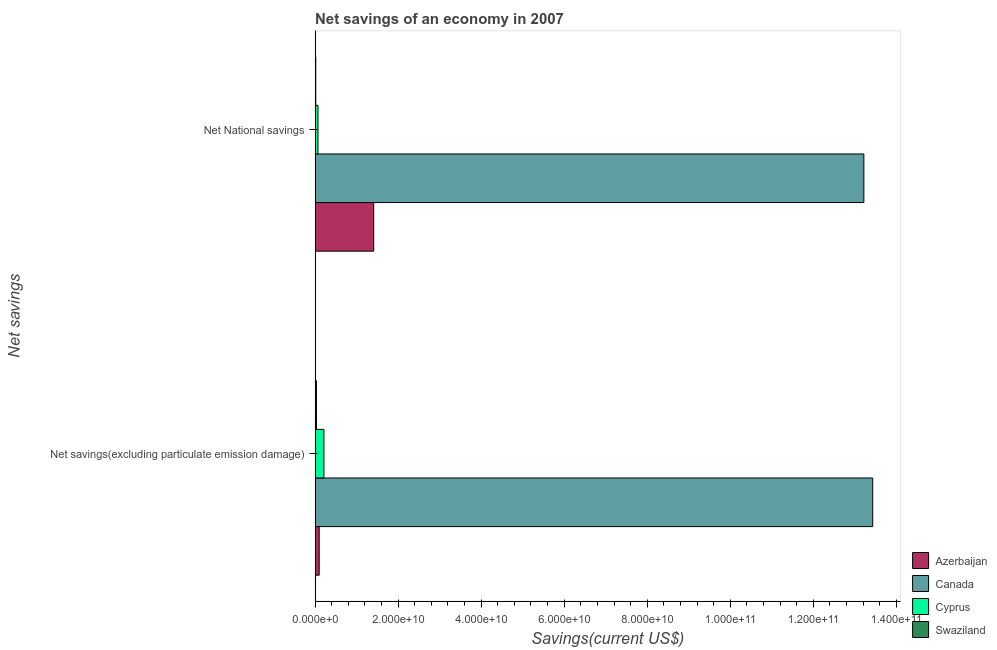Are the number of bars per tick equal to the number of legend labels?
Give a very brief answer. Yes. Are the number of bars on each tick of the Y-axis equal?
Give a very brief answer. Yes. How many bars are there on the 1st tick from the top?
Make the answer very short. 4. How many bars are there on the 1st tick from the bottom?
Ensure brevity in your answer.  4. What is the label of the 1st group of bars from the top?
Offer a terse response. Net National savings. What is the net savings(excluding particulate emission damage) in Cyprus?
Make the answer very short. 2.13e+09. Across all countries, what is the maximum net national savings?
Your answer should be compact. 1.32e+11. Across all countries, what is the minimum net national savings?
Your response must be concise. 1.61e+08. In which country was the net savings(excluding particulate emission damage) maximum?
Make the answer very short. Canada. In which country was the net national savings minimum?
Give a very brief answer. Swaziland. What is the total net national savings in the graph?
Provide a succinct answer. 1.47e+11. What is the difference between the net savings(excluding particulate emission damage) in Cyprus and that in Canada?
Ensure brevity in your answer.  -1.32e+11. What is the difference between the net savings(excluding particulate emission damage) in Canada and the net national savings in Swaziland?
Your response must be concise. 1.34e+11. What is the average net savings(excluding particulate emission damage) per country?
Make the answer very short. 3.44e+1. What is the difference between the net national savings and net savings(excluding particulate emission damage) in Swaziland?
Offer a terse response. -1.59e+08. In how many countries, is the net savings(excluding particulate emission damage) greater than 20000000000 US$?
Provide a short and direct response. 1. What is the ratio of the net savings(excluding particulate emission damage) in Cyprus to that in Canada?
Ensure brevity in your answer.  0.02. Is the net national savings in Swaziland less than that in Canada?
Give a very brief answer. Yes. What does the 2nd bar from the top in Net National savings represents?
Ensure brevity in your answer.  Cyprus. What does the 4th bar from the bottom in Net savings(excluding particulate emission damage) represents?
Provide a short and direct response. Swaziland. How many countries are there in the graph?
Ensure brevity in your answer.  4. What is the difference between two consecutive major ticks on the X-axis?
Provide a short and direct response. 2.00e+1. Are the values on the major ticks of X-axis written in scientific E-notation?
Provide a succinct answer. Yes. Where does the legend appear in the graph?
Offer a terse response. Bottom right. How are the legend labels stacked?
Offer a very short reply. Vertical. What is the title of the graph?
Your answer should be very brief. Net savings of an economy in 2007. What is the label or title of the X-axis?
Your answer should be compact. Savings(current US$). What is the label or title of the Y-axis?
Give a very brief answer. Net savings. What is the Savings(current US$) of Azerbaijan in Net savings(excluding particulate emission damage)?
Provide a succinct answer. 9.83e+08. What is the Savings(current US$) in Canada in Net savings(excluding particulate emission damage)?
Keep it short and to the point. 1.34e+11. What is the Savings(current US$) of Cyprus in Net savings(excluding particulate emission damage)?
Offer a very short reply. 2.13e+09. What is the Savings(current US$) in Swaziland in Net savings(excluding particulate emission damage)?
Provide a short and direct response. 3.20e+08. What is the Savings(current US$) in Azerbaijan in Net National savings?
Provide a short and direct response. 1.41e+1. What is the Savings(current US$) in Canada in Net National savings?
Offer a very short reply. 1.32e+11. What is the Savings(current US$) of Cyprus in Net National savings?
Your answer should be compact. 6.94e+08. What is the Savings(current US$) of Swaziland in Net National savings?
Your answer should be compact. 1.61e+08. Across all Net savings, what is the maximum Savings(current US$) of Azerbaijan?
Provide a succinct answer. 1.41e+1. Across all Net savings, what is the maximum Savings(current US$) of Canada?
Ensure brevity in your answer.  1.34e+11. Across all Net savings, what is the maximum Savings(current US$) in Cyprus?
Give a very brief answer. 2.13e+09. Across all Net savings, what is the maximum Savings(current US$) of Swaziland?
Your response must be concise. 3.20e+08. Across all Net savings, what is the minimum Savings(current US$) of Azerbaijan?
Give a very brief answer. 9.83e+08. Across all Net savings, what is the minimum Savings(current US$) of Canada?
Offer a very short reply. 1.32e+11. Across all Net savings, what is the minimum Savings(current US$) in Cyprus?
Your answer should be compact. 6.94e+08. Across all Net savings, what is the minimum Savings(current US$) in Swaziland?
Offer a terse response. 1.61e+08. What is the total Savings(current US$) in Azerbaijan in the graph?
Your answer should be compact. 1.51e+1. What is the total Savings(current US$) of Canada in the graph?
Provide a succinct answer. 2.67e+11. What is the total Savings(current US$) of Cyprus in the graph?
Your answer should be compact. 2.82e+09. What is the total Savings(current US$) of Swaziland in the graph?
Make the answer very short. 4.81e+08. What is the difference between the Savings(current US$) of Azerbaijan in Net savings(excluding particulate emission damage) and that in Net National savings?
Your response must be concise. -1.31e+1. What is the difference between the Savings(current US$) of Canada in Net savings(excluding particulate emission damage) and that in Net National savings?
Ensure brevity in your answer.  2.13e+09. What is the difference between the Savings(current US$) of Cyprus in Net savings(excluding particulate emission damage) and that in Net National savings?
Give a very brief answer. 1.44e+09. What is the difference between the Savings(current US$) in Swaziland in Net savings(excluding particulate emission damage) and that in Net National savings?
Make the answer very short. 1.59e+08. What is the difference between the Savings(current US$) in Azerbaijan in Net savings(excluding particulate emission damage) and the Savings(current US$) in Canada in Net National savings?
Offer a terse response. -1.31e+11. What is the difference between the Savings(current US$) of Azerbaijan in Net savings(excluding particulate emission damage) and the Savings(current US$) of Cyprus in Net National savings?
Offer a terse response. 2.88e+08. What is the difference between the Savings(current US$) of Azerbaijan in Net savings(excluding particulate emission damage) and the Savings(current US$) of Swaziland in Net National savings?
Offer a very short reply. 8.21e+08. What is the difference between the Savings(current US$) of Canada in Net savings(excluding particulate emission damage) and the Savings(current US$) of Cyprus in Net National savings?
Offer a very short reply. 1.34e+11. What is the difference between the Savings(current US$) of Canada in Net savings(excluding particulate emission damage) and the Savings(current US$) of Swaziland in Net National savings?
Your answer should be compact. 1.34e+11. What is the difference between the Savings(current US$) of Cyprus in Net savings(excluding particulate emission damage) and the Savings(current US$) of Swaziland in Net National savings?
Your response must be concise. 1.97e+09. What is the average Savings(current US$) in Azerbaijan per Net savings?
Offer a terse response. 7.55e+09. What is the average Savings(current US$) of Canada per Net savings?
Offer a terse response. 1.33e+11. What is the average Savings(current US$) in Cyprus per Net savings?
Ensure brevity in your answer.  1.41e+09. What is the average Savings(current US$) of Swaziland per Net savings?
Offer a very short reply. 2.41e+08. What is the difference between the Savings(current US$) in Azerbaijan and Savings(current US$) in Canada in Net savings(excluding particulate emission damage)?
Keep it short and to the point. -1.33e+11. What is the difference between the Savings(current US$) of Azerbaijan and Savings(current US$) of Cyprus in Net savings(excluding particulate emission damage)?
Your answer should be compact. -1.15e+09. What is the difference between the Savings(current US$) in Azerbaijan and Savings(current US$) in Swaziland in Net savings(excluding particulate emission damage)?
Give a very brief answer. 6.63e+08. What is the difference between the Savings(current US$) of Canada and Savings(current US$) of Cyprus in Net savings(excluding particulate emission damage)?
Your response must be concise. 1.32e+11. What is the difference between the Savings(current US$) in Canada and Savings(current US$) in Swaziland in Net savings(excluding particulate emission damage)?
Make the answer very short. 1.34e+11. What is the difference between the Savings(current US$) of Cyprus and Savings(current US$) of Swaziland in Net savings(excluding particulate emission damage)?
Provide a succinct answer. 1.81e+09. What is the difference between the Savings(current US$) in Azerbaijan and Savings(current US$) in Canada in Net National savings?
Provide a succinct answer. -1.18e+11. What is the difference between the Savings(current US$) of Azerbaijan and Savings(current US$) of Cyprus in Net National savings?
Ensure brevity in your answer.  1.34e+1. What is the difference between the Savings(current US$) of Azerbaijan and Savings(current US$) of Swaziland in Net National savings?
Provide a succinct answer. 1.40e+1. What is the difference between the Savings(current US$) in Canada and Savings(current US$) in Cyprus in Net National savings?
Offer a terse response. 1.31e+11. What is the difference between the Savings(current US$) in Canada and Savings(current US$) in Swaziland in Net National savings?
Provide a short and direct response. 1.32e+11. What is the difference between the Savings(current US$) in Cyprus and Savings(current US$) in Swaziland in Net National savings?
Your response must be concise. 5.33e+08. What is the ratio of the Savings(current US$) of Azerbaijan in Net savings(excluding particulate emission damage) to that in Net National savings?
Your answer should be very brief. 0.07. What is the ratio of the Savings(current US$) in Canada in Net savings(excluding particulate emission damage) to that in Net National savings?
Offer a very short reply. 1.02. What is the ratio of the Savings(current US$) in Cyprus in Net savings(excluding particulate emission damage) to that in Net National savings?
Offer a terse response. 3.07. What is the ratio of the Savings(current US$) in Swaziland in Net savings(excluding particulate emission damage) to that in Net National savings?
Keep it short and to the point. 1.98. What is the difference between the highest and the second highest Savings(current US$) in Azerbaijan?
Your answer should be very brief. 1.31e+1. What is the difference between the highest and the second highest Savings(current US$) in Canada?
Your answer should be very brief. 2.13e+09. What is the difference between the highest and the second highest Savings(current US$) of Cyprus?
Your answer should be very brief. 1.44e+09. What is the difference between the highest and the second highest Savings(current US$) in Swaziland?
Your answer should be compact. 1.59e+08. What is the difference between the highest and the lowest Savings(current US$) of Azerbaijan?
Make the answer very short. 1.31e+1. What is the difference between the highest and the lowest Savings(current US$) in Canada?
Provide a succinct answer. 2.13e+09. What is the difference between the highest and the lowest Savings(current US$) in Cyprus?
Offer a terse response. 1.44e+09. What is the difference between the highest and the lowest Savings(current US$) of Swaziland?
Offer a terse response. 1.59e+08. 